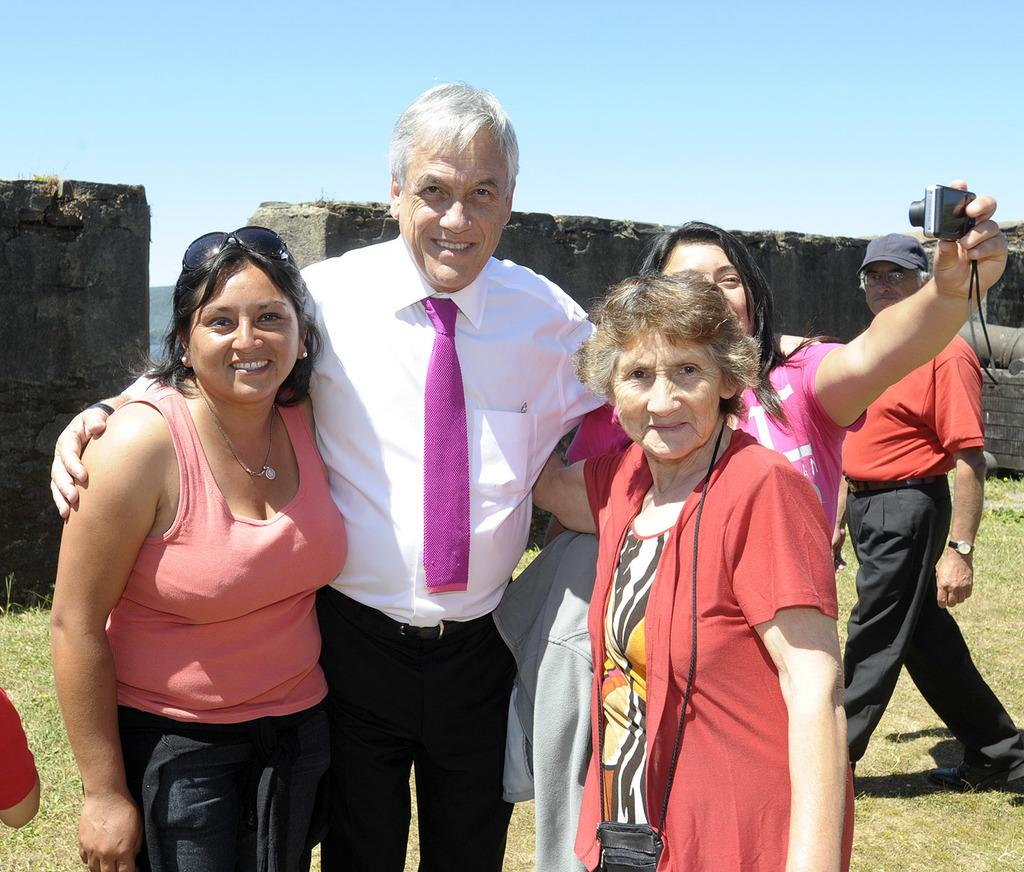How many people are in the image? There is a group of people in the image. What are some of the people in the image doing? Some people are standing, and a man is walking on the grass. Where is the woman located in the image? The woman is on the right side of the image. What is the woman holding in the image? The woman is holding a camera. What is the price of the tent in the image? There is no tent present in the image, so it is not possible to determine its price. 